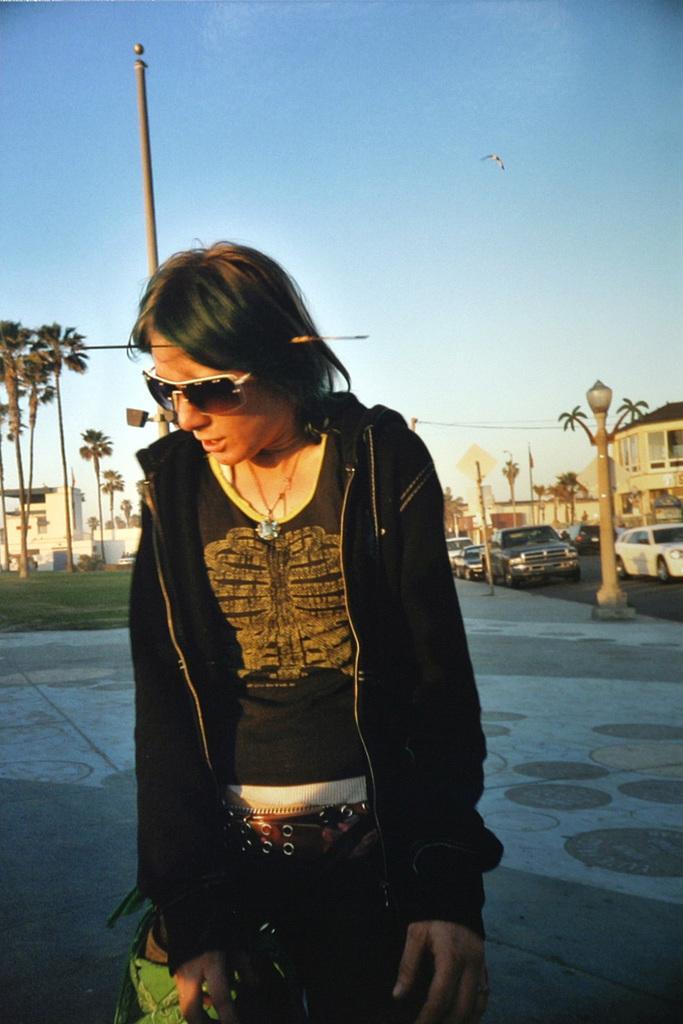How would you summarize this image in a sentence or two? In this image we can see a person wearing black color dress, goggles standing on the ground and in the background of the image there are some trees, vehicles which are parked on the road, houses, poles and top of the image there is clear sky. 